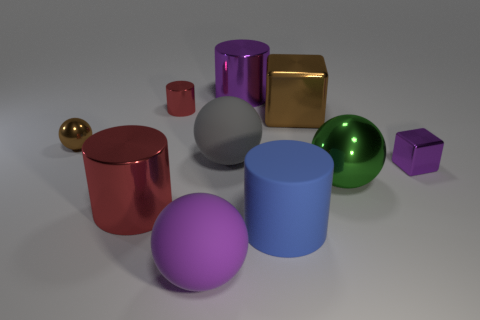How many red things are either metal cylinders or small shiny cylinders?
Keep it short and to the point. 2. How many spheres are the same color as the large metal cube?
Ensure brevity in your answer.  1. How many blocks are either brown objects or small purple shiny objects?
Give a very brief answer. 2. There is a large shiny cylinder left of the gray object; what is its color?
Provide a short and direct response. Red. What is the shape of the green metallic thing that is the same size as the brown cube?
Make the answer very short. Sphere. There is a blue matte cylinder; what number of big shiny objects are to the right of it?
Keep it short and to the point. 2. What number of things are either purple shiny cylinders or matte objects?
Ensure brevity in your answer.  4. There is a big metal object that is in front of the big block and right of the blue thing; what shape is it?
Provide a succinct answer. Sphere. How many tiny cyan matte cubes are there?
Offer a very short reply. 0. There is another tiny sphere that is made of the same material as the green sphere; what is its color?
Your answer should be very brief. Brown. 